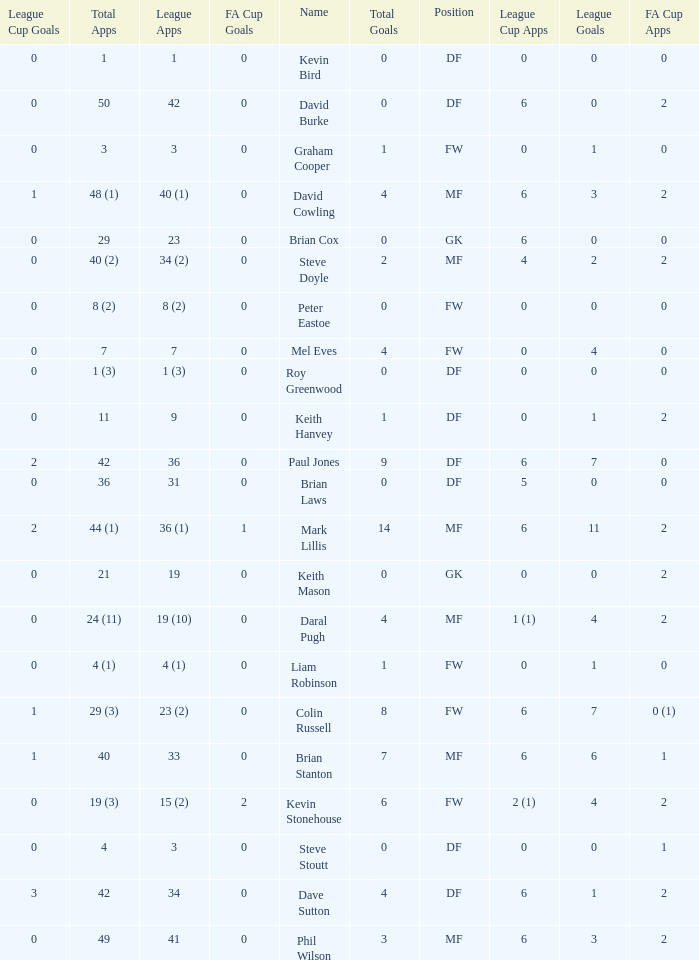What is the most total goals for a player having 0 FA Cup goals and 41 League appearances? 3.0. 